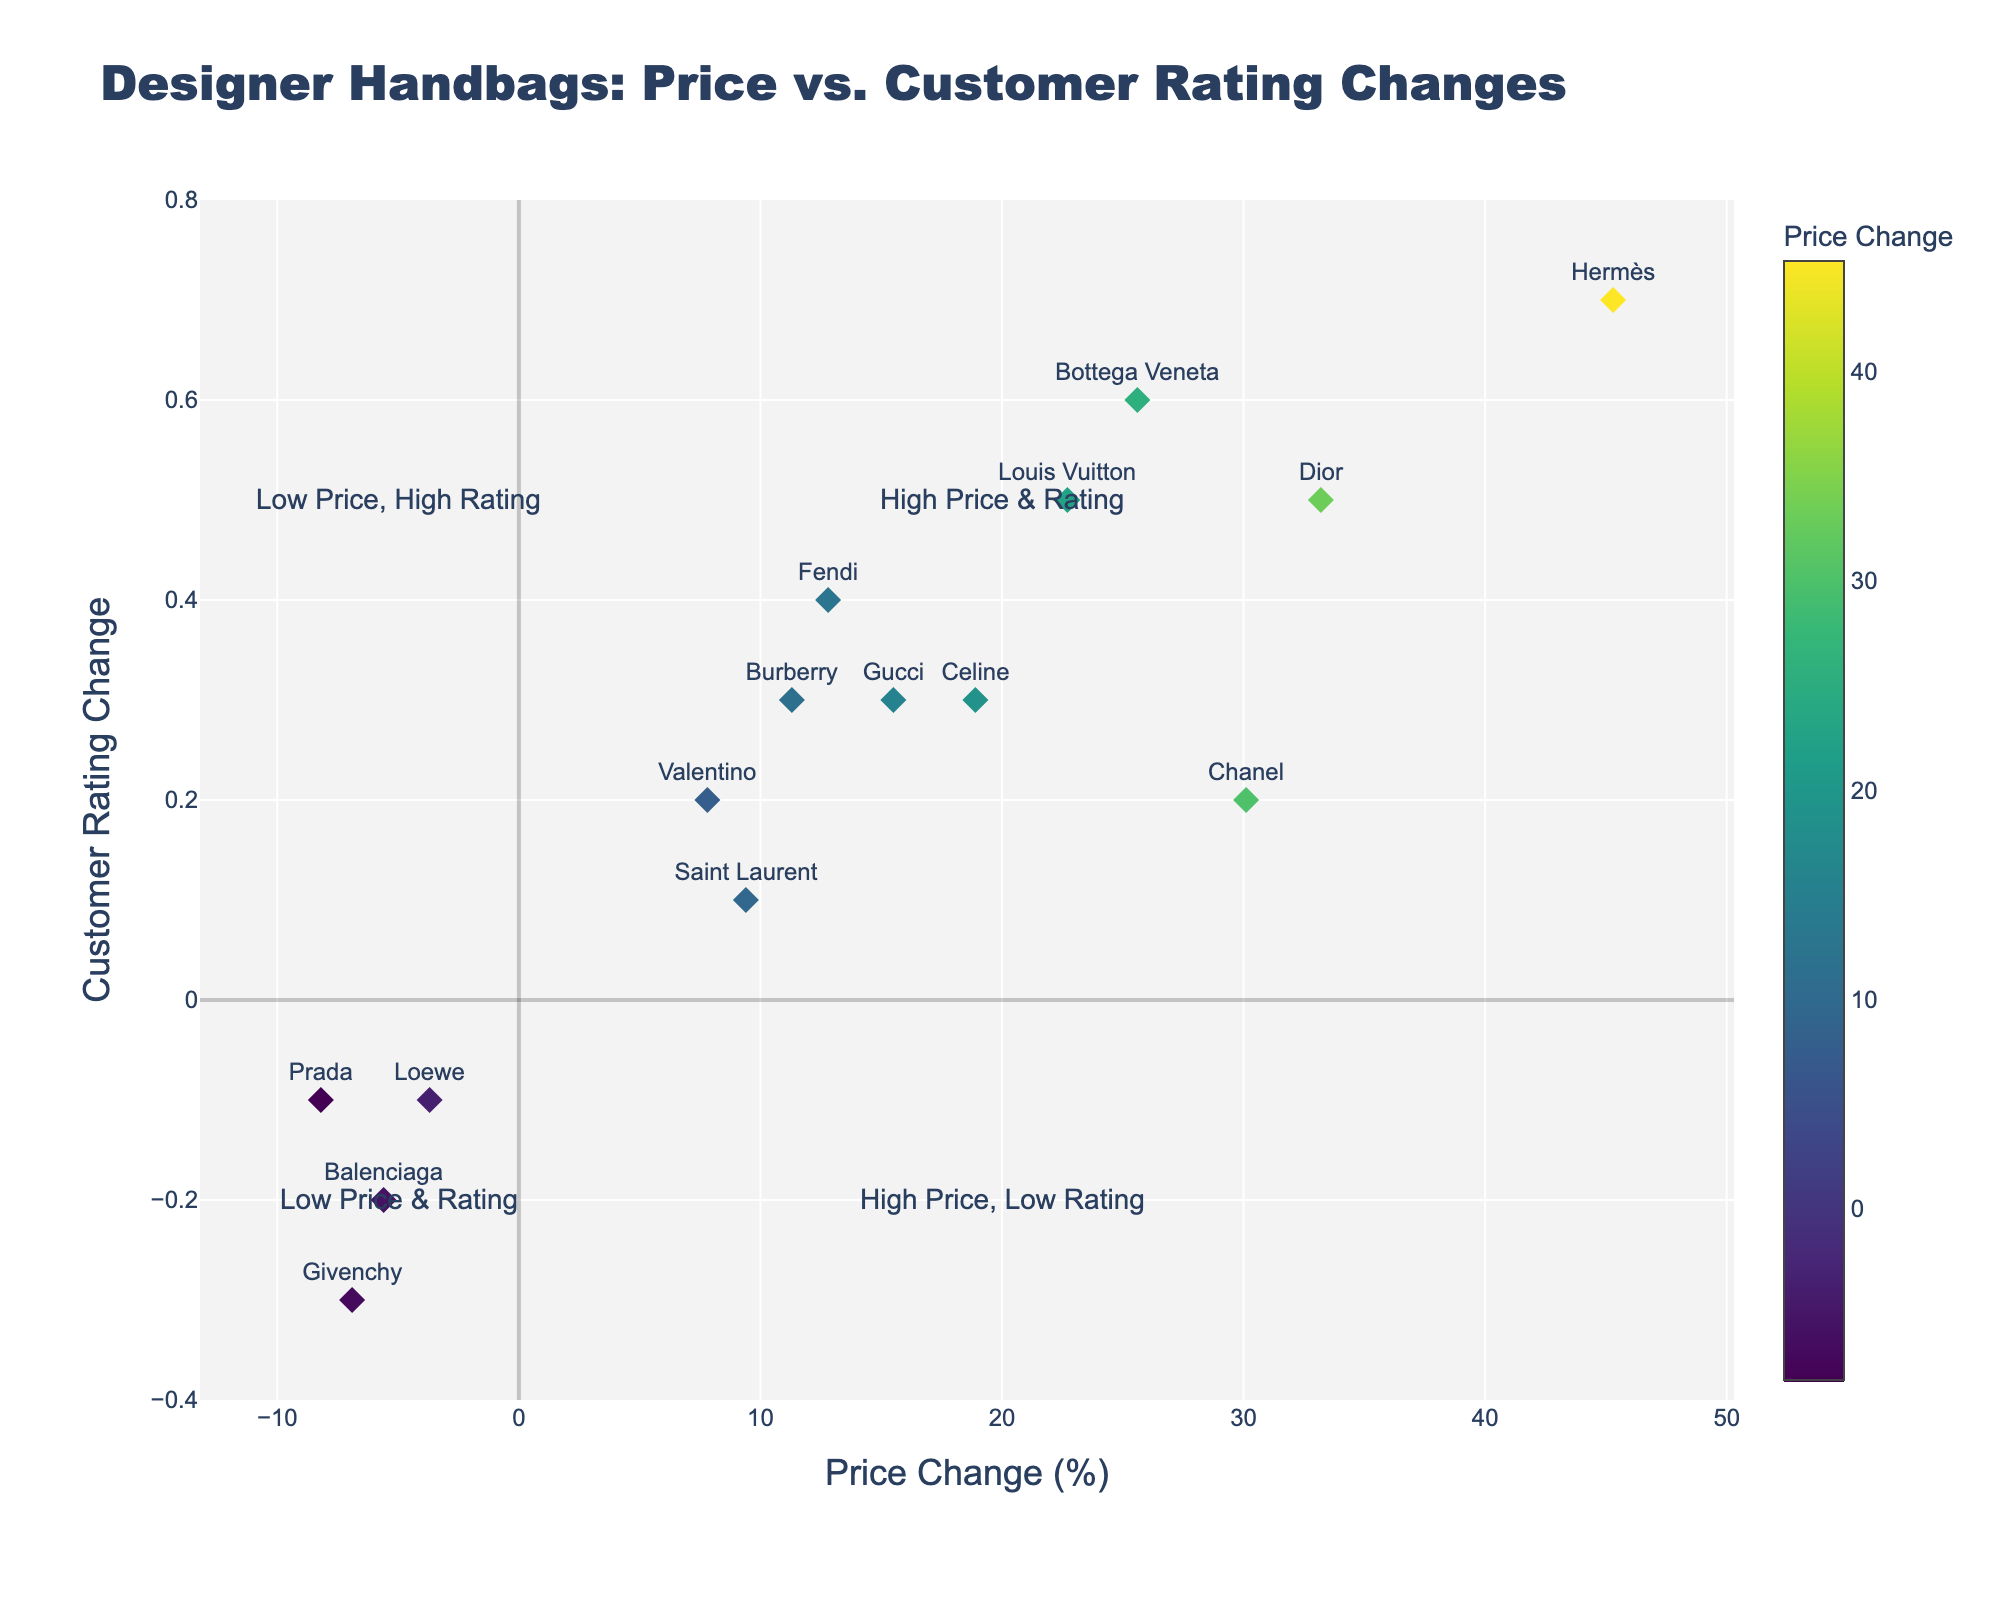What's the title of the plot? The title of the plot can be seen at the top of the figure. It is written in large, bold text. The title is 'Designer Handbags: Price vs. Customer Rating Changes.'
Answer: Designer Handbags: Price vs. Customer Rating Changes What does the x-axis represent? The x-axis label is located at the bottom of the plot. It is labeled 'Price Change (%)', indicating that the x-axis represents percentage changes in price.
Answer: Price Change (%) Which handbag brand has the highest price change and what is that change? By looking at the plot, we identify the data point furthest to the right. The label above this point indicates it belongs to Hermès, with a price change of around 45.3%.
Answer: Hermès, 45.3% How many handbag brands have a negative change in both price and customer rating? Negative values for price changes are on the left of the zero line on the x-axis, and negative values for customer rating changes are below the zero line on the y-axis. There are three points in the bottom-left quadrant: Prada, Balenciaga, and Givenchy.
Answer: 3 Which brand is closest to having no change in either price or customer rating? The brand closest to the origin (0, 0) of the plot would have the smallest absolute changes in both price and customer rating. The data point closest to (0, 0) represents Valentino, with a price change of 7.8% and a rating change of 0.2.
Answer: Valentino What can you infer about the relationship between price changes and customer ratings? From the plot, we observe the general trend by looking at the scattered data points. Most points with higher price changes tend to have positive rating changes, suggesting a positive correlation between price increases and customer ratings.
Answer: Positive correlation Which marketplace shows the largest price decrease, and for which brand? Identifying points with the lowest x-axis values (leftmost points) and reading their labels reveals that Farfetch shows a price decrease for the Prada brand with a decrease of 8.2%.
Answer: Farfetch, Prada Which brand is considered high in both price and customer rating? Points falling in the top-right quadrant indicate high price and high customer rating changes. In this quadrant, Louis Vuitton, Hermès, Bottega Veneta, and Dior reside. Hermès has the highest changes in both price and rating with values of 45.3% and 0.7 respectively.
Answer: Hermès Which handbag brands have a customer rating change of 0.5? Looking at the y-axis and identifying points at y=0.5, the corresponding labels are Louis Vuitton and Dior.
Answer: Louis Vuitton, Dior 